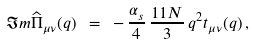<formula> <loc_0><loc_0><loc_500><loc_500>\Im m \widehat { \Pi } _ { \mu \nu } ( q ) \ = \ - \, \frac { \alpha _ { s } } { 4 } \, \frac { 1 1 N } { 3 } \, q ^ { 2 } t _ { \mu \nu } ( q ) \, ,</formula> 